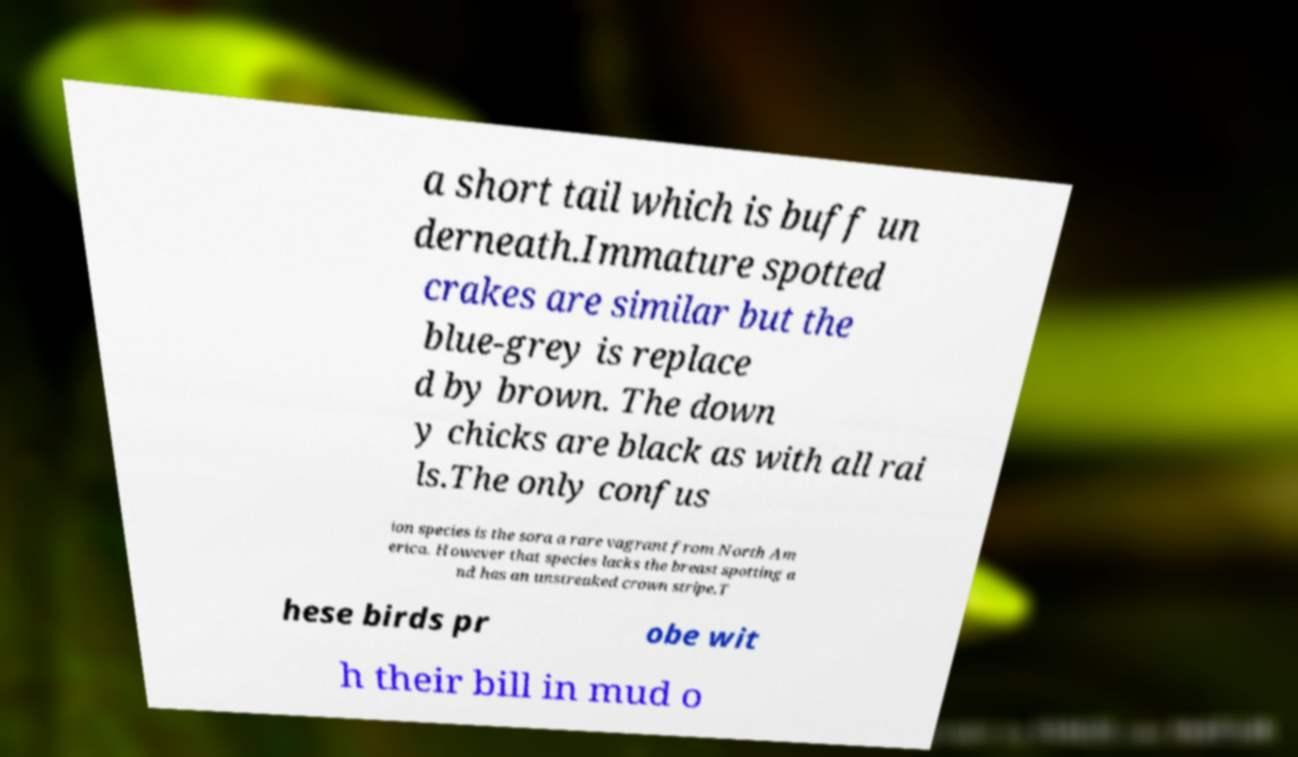Please identify and transcribe the text found in this image. a short tail which is buff un derneath.Immature spotted crakes are similar but the blue-grey is replace d by brown. The down y chicks are black as with all rai ls.The only confus ion species is the sora a rare vagrant from North Am erica. However that species lacks the breast spotting a nd has an unstreaked crown stripe.T hese birds pr obe wit h their bill in mud o 